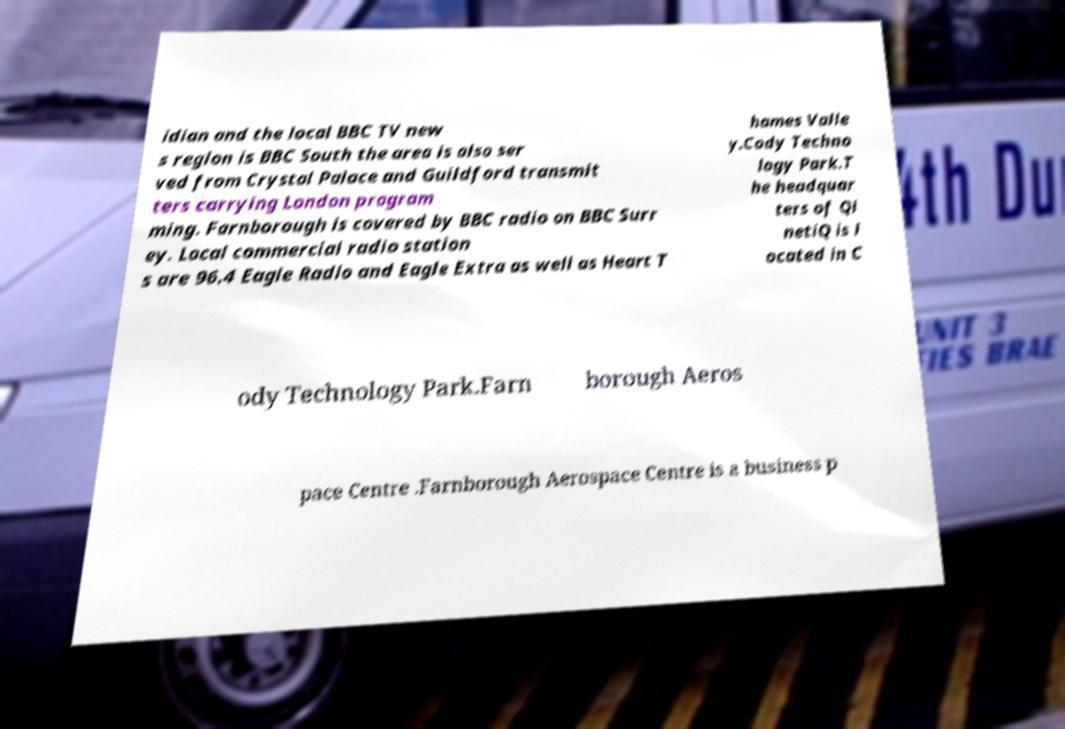For documentation purposes, I need the text within this image transcribed. Could you provide that? idian and the local BBC TV new s region is BBC South the area is also ser ved from Crystal Palace and Guildford transmit ters carrying London program ming. Farnborough is covered by BBC radio on BBC Surr ey. Local commercial radio station s are 96.4 Eagle Radio and Eagle Extra as well as Heart T hames Valle y.Cody Techno logy Park.T he headquar ters of Qi netiQ is l ocated in C ody Technology Park.Farn borough Aeros pace Centre .Farnborough Aerospace Centre is a business p 